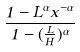<formula> <loc_0><loc_0><loc_500><loc_500>\frac { 1 - L ^ { \alpha } x ^ { - \alpha } } { 1 - ( \frac { L } { H } ) ^ { \alpha } }</formula> 